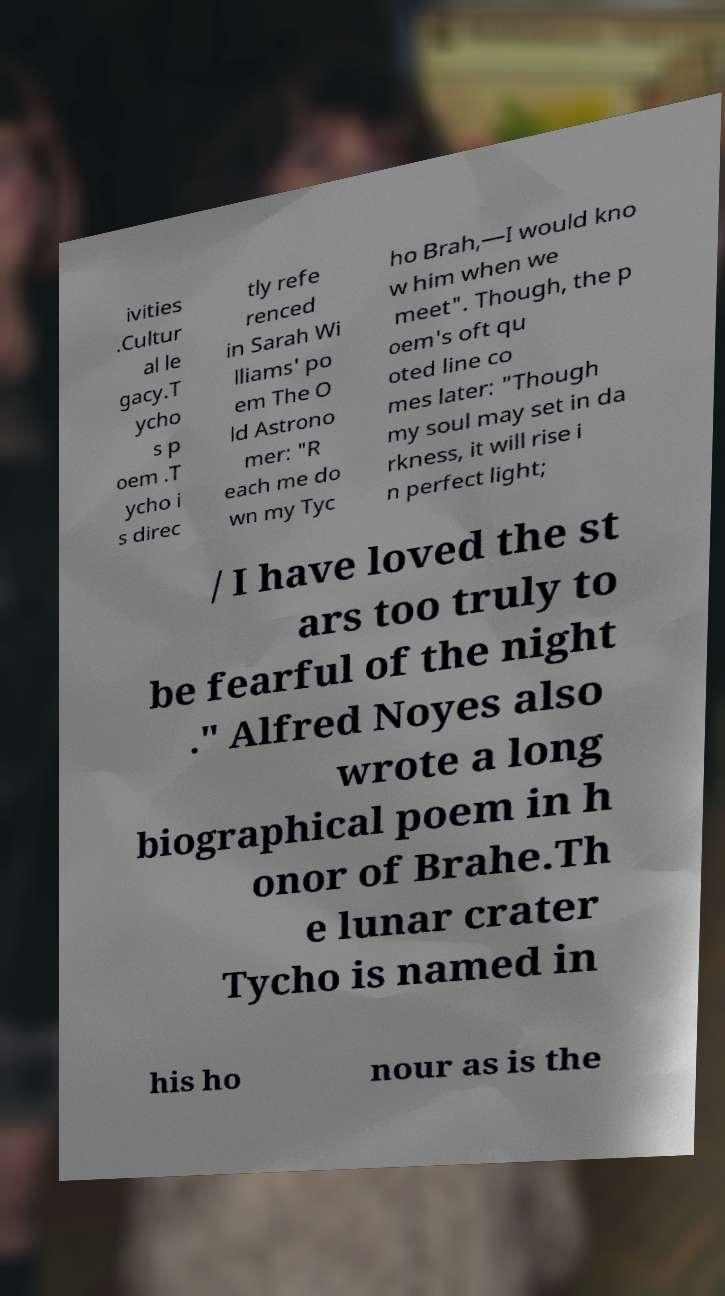Can you accurately transcribe the text from the provided image for me? ivities .Cultur al le gacy.T ycho s p oem .T ycho i s direc tly refe renced in Sarah Wi lliams' po em The O ld Astrono mer: "R each me do wn my Tyc ho Brah,—I would kno w him when we meet". Though, the p oem's oft qu oted line co mes later: "Though my soul may set in da rkness, it will rise i n perfect light; / I have loved the st ars too truly to be fearful of the night ." Alfred Noyes also wrote a long biographical poem in h onor of Brahe.Th e lunar crater Tycho is named in his ho nour as is the 